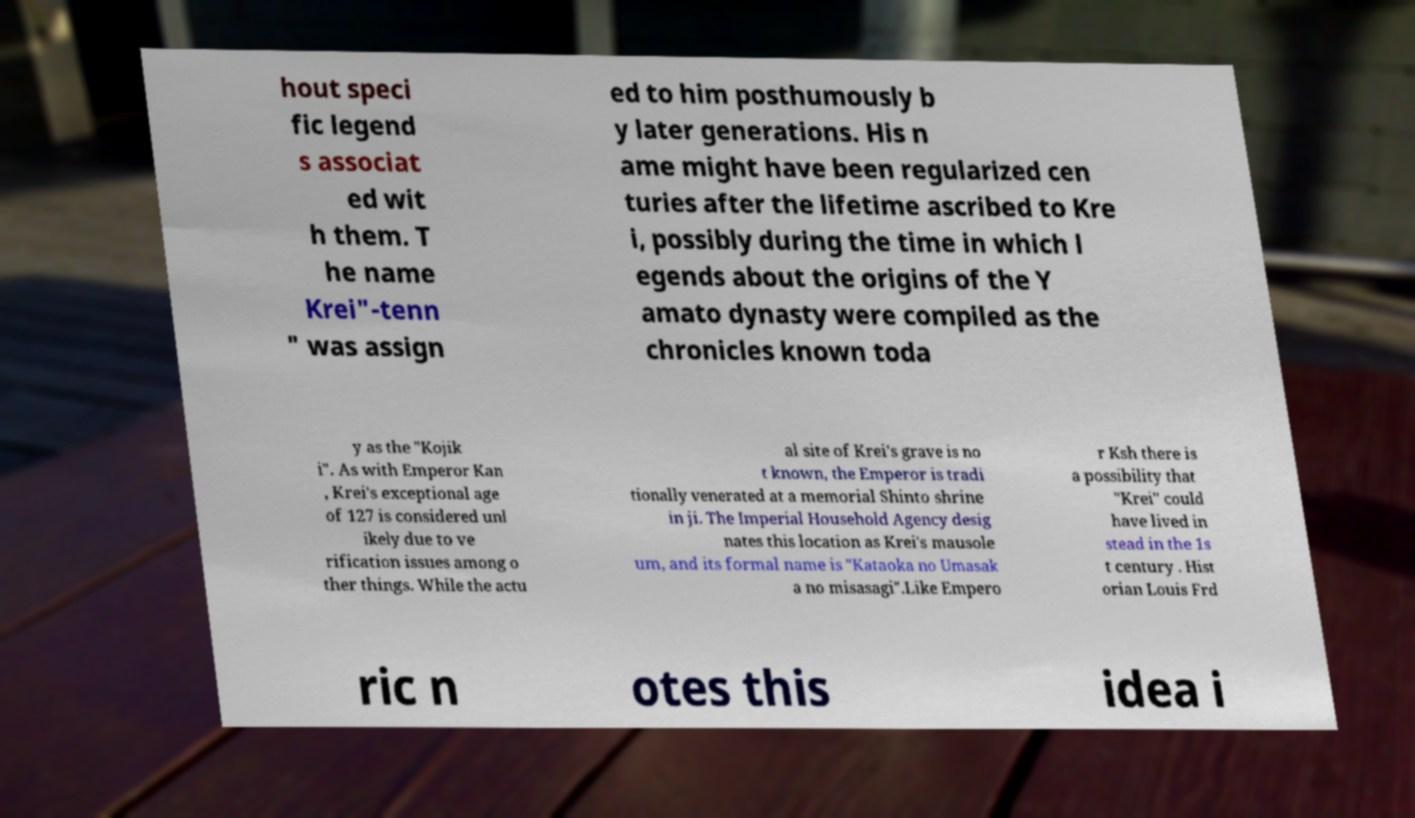I need the written content from this picture converted into text. Can you do that? hout speci fic legend s associat ed wit h them. T he name Krei"-tenn " was assign ed to him posthumously b y later generations. His n ame might have been regularized cen turies after the lifetime ascribed to Kre i, possibly during the time in which l egends about the origins of the Y amato dynasty were compiled as the chronicles known toda y as the "Kojik i". As with Emperor Kan , Krei's exceptional age of 127 is considered unl ikely due to ve rification issues among o ther things. While the actu al site of Krei's grave is no t known, the Emperor is tradi tionally venerated at a memorial Shinto shrine in ji. The Imperial Household Agency desig nates this location as Krei's mausole um, and its formal name is "Kataoka no Umasak a no misasagi".Like Empero r Ksh there is a possibility that "Krei" could have lived in stead in the 1s t century . Hist orian Louis Frd ric n otes this idea i 